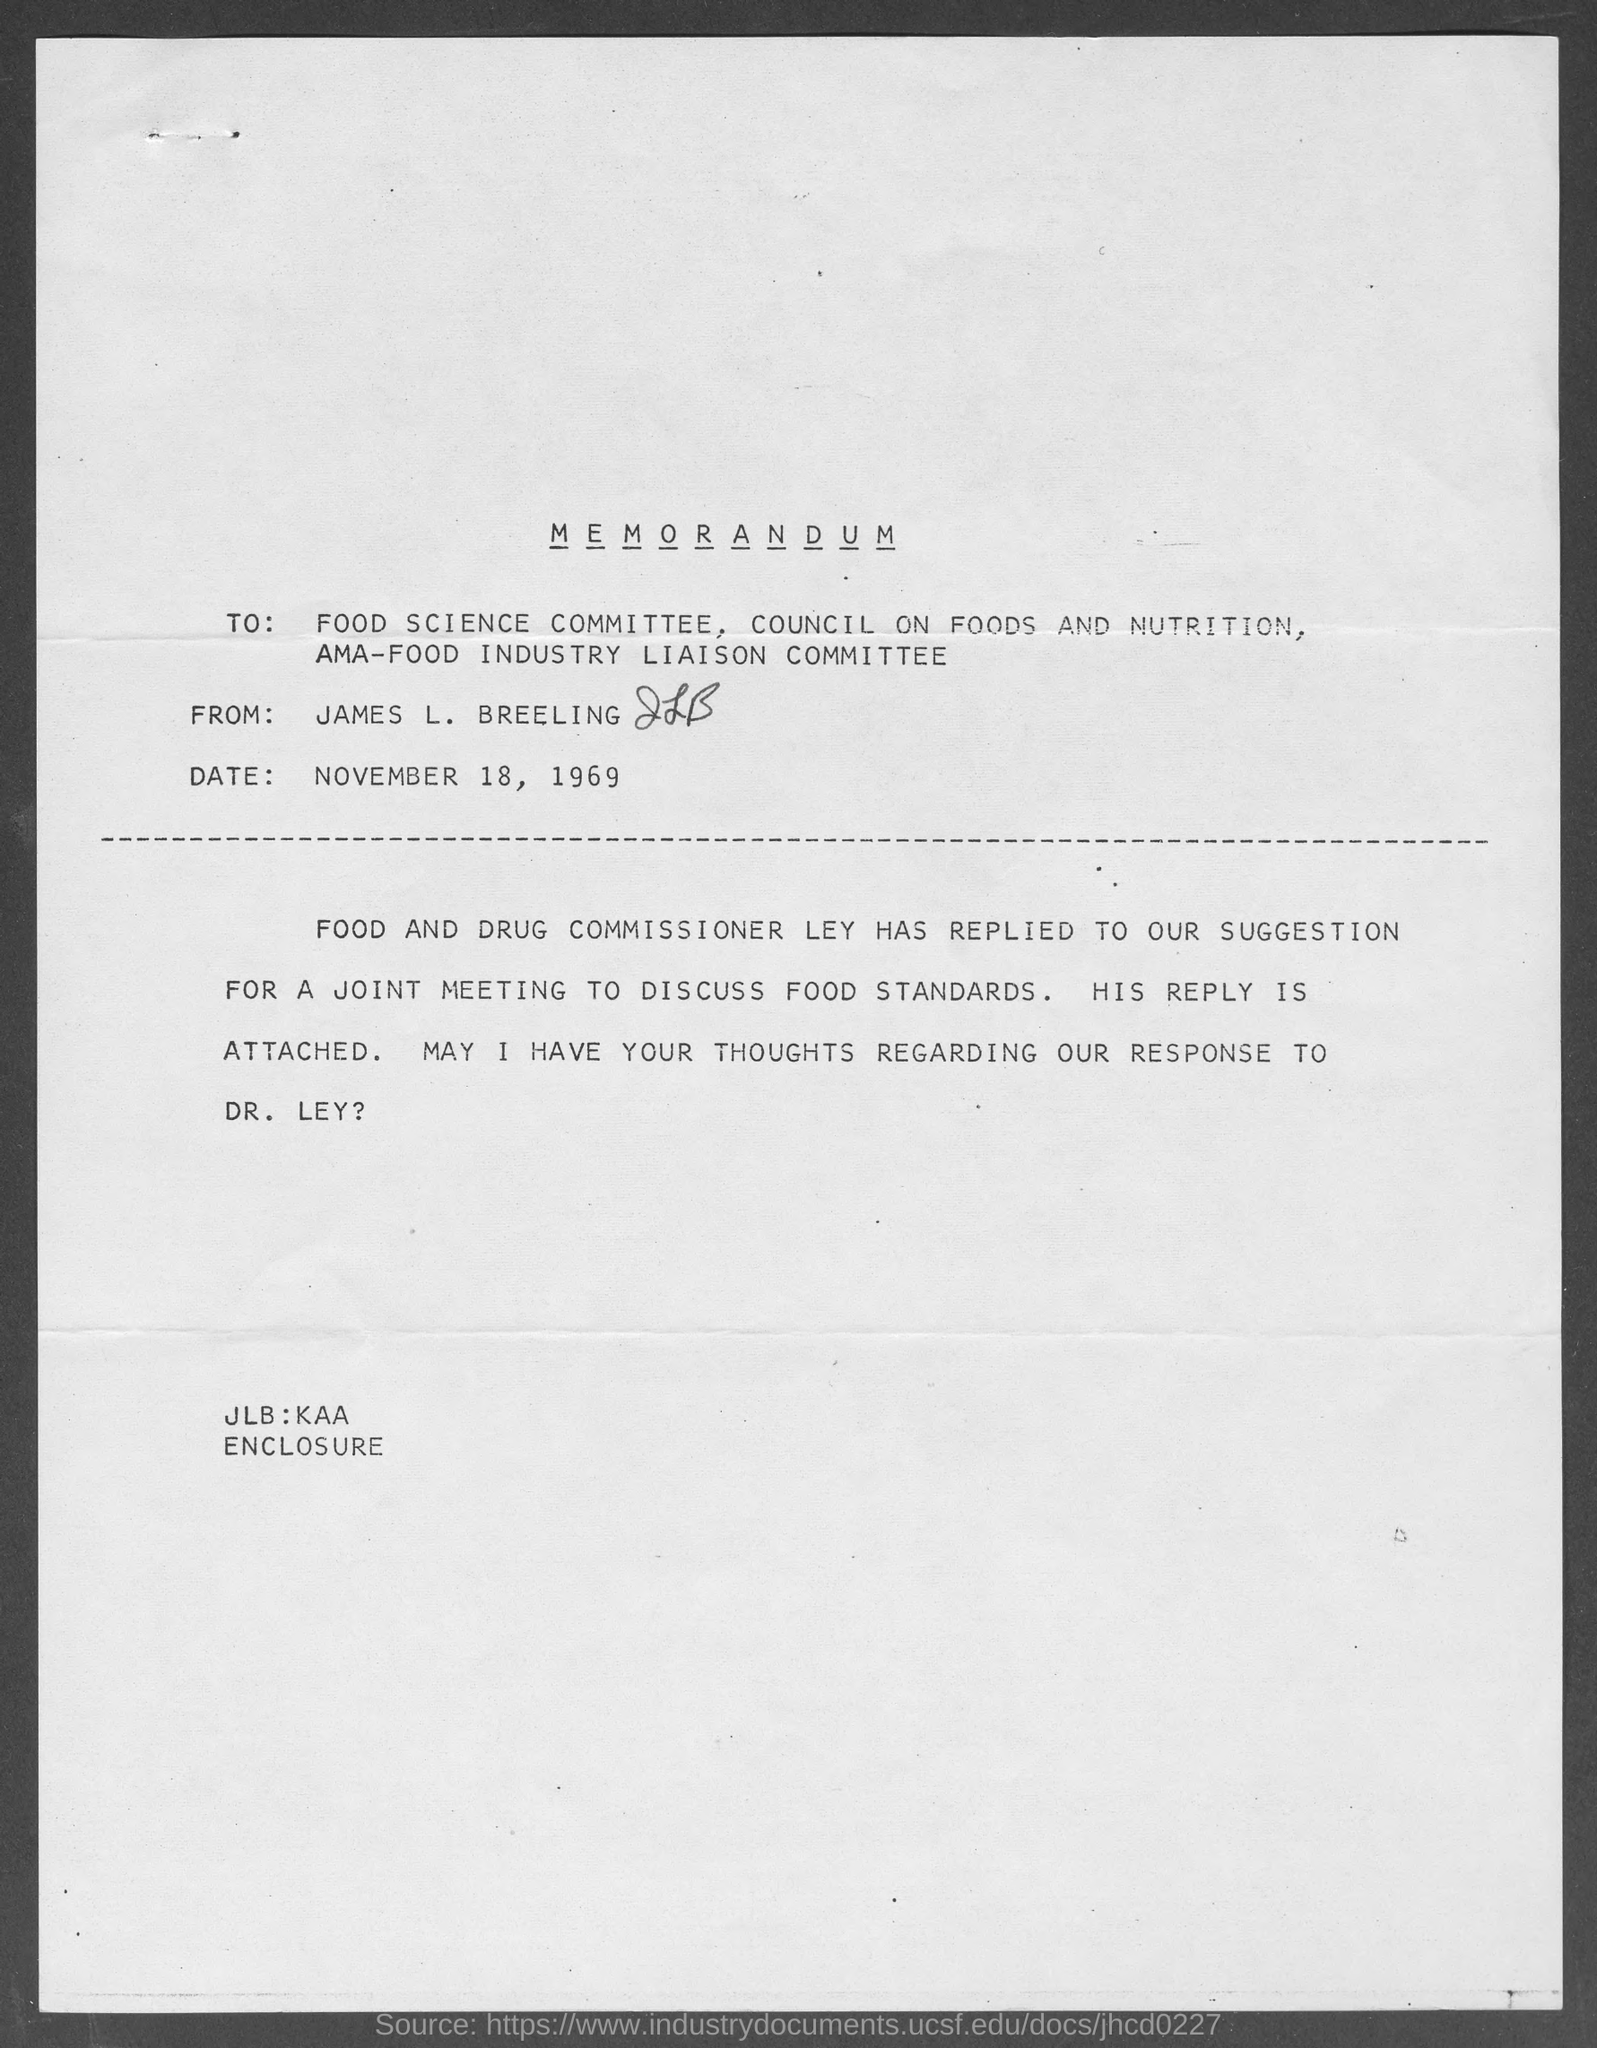Give some essential details in this illustration. The memorandum is dated November 18, 1969. The from address in a memorandum is James L. Breeling. 